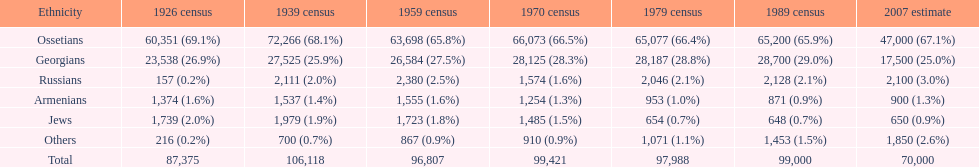In 1926, which demographic had the greatest number of inhabitants? Ossetians. 